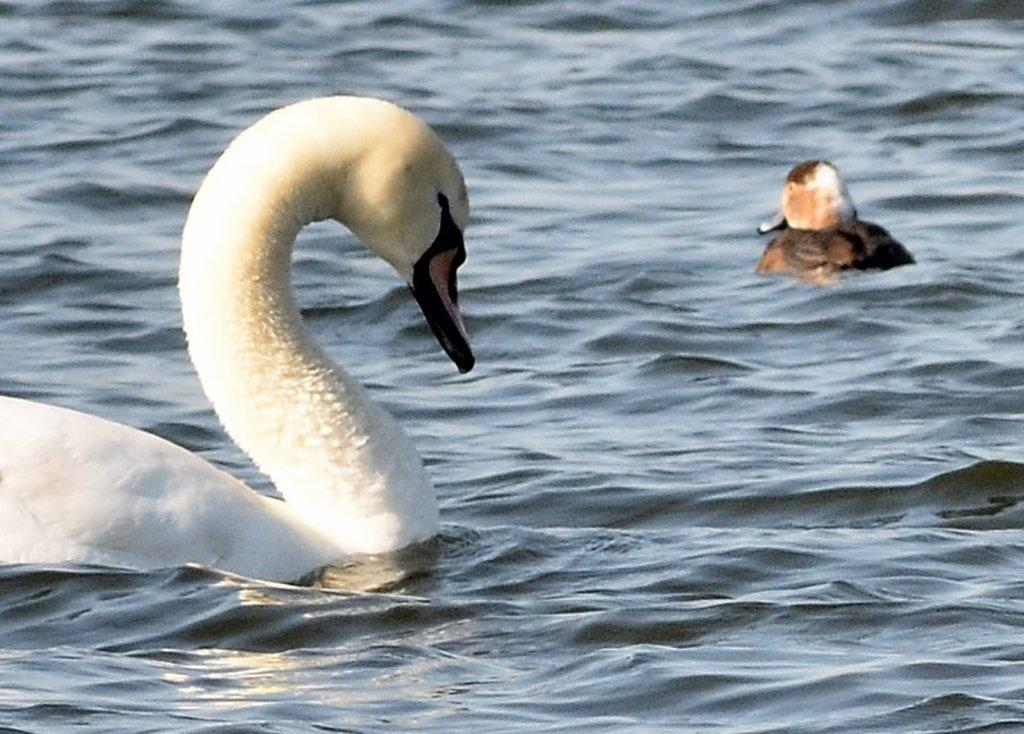How many birds are in the image? There are two birds in the image. What colors are the birds? One bird is white in color, and the other bird is white and brown in color. Where are the birds located in the image? Both birds are in the water. What type of lock can be seen on the orange bird in the image? There is no orange bird or lock present in the image. 